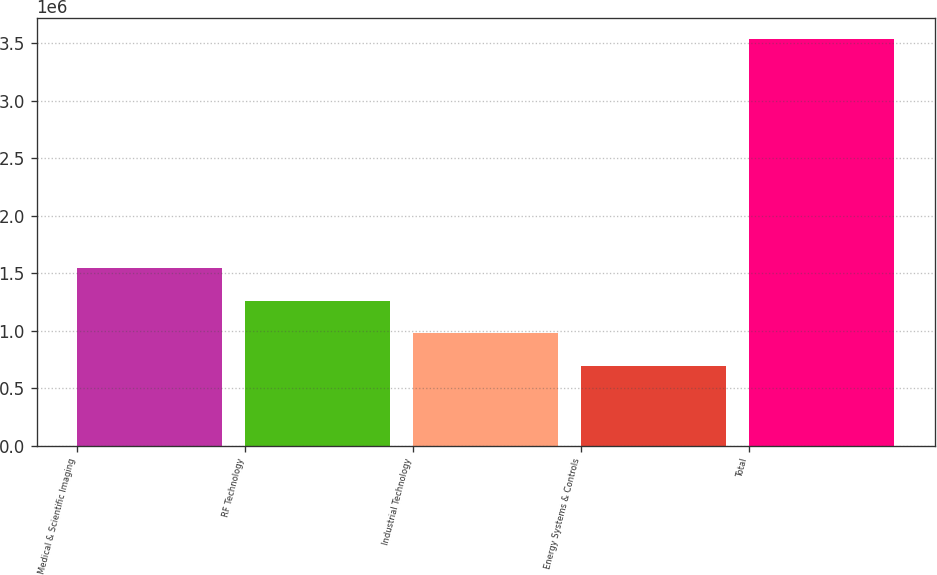Convert chart to OTSL. <chart><loc_0><loc_0><loc_500><loc_500><bar_chart><fcel>Medical & Scientific Imaging<fcel>RF Technology<fcel>Industrial Technology<fcel>Energy Systems & Controls<fcel>Total<nl><fcel>1.54592e+06<fcel>1.26132e+06<fcel>976730<fcel>692136<fcel>3.53808e+06<nl></chart> 